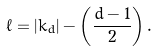<formula> <loc_0><loc_0><loc_500><loc_500>\ell = | k _ { d } | - \left ( \frac { d - 1 } { 2 } \right ) .</formula> 